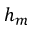<formula> <loc_0><loc_0><loc_500><loc_500>h _ { m }</formula> 